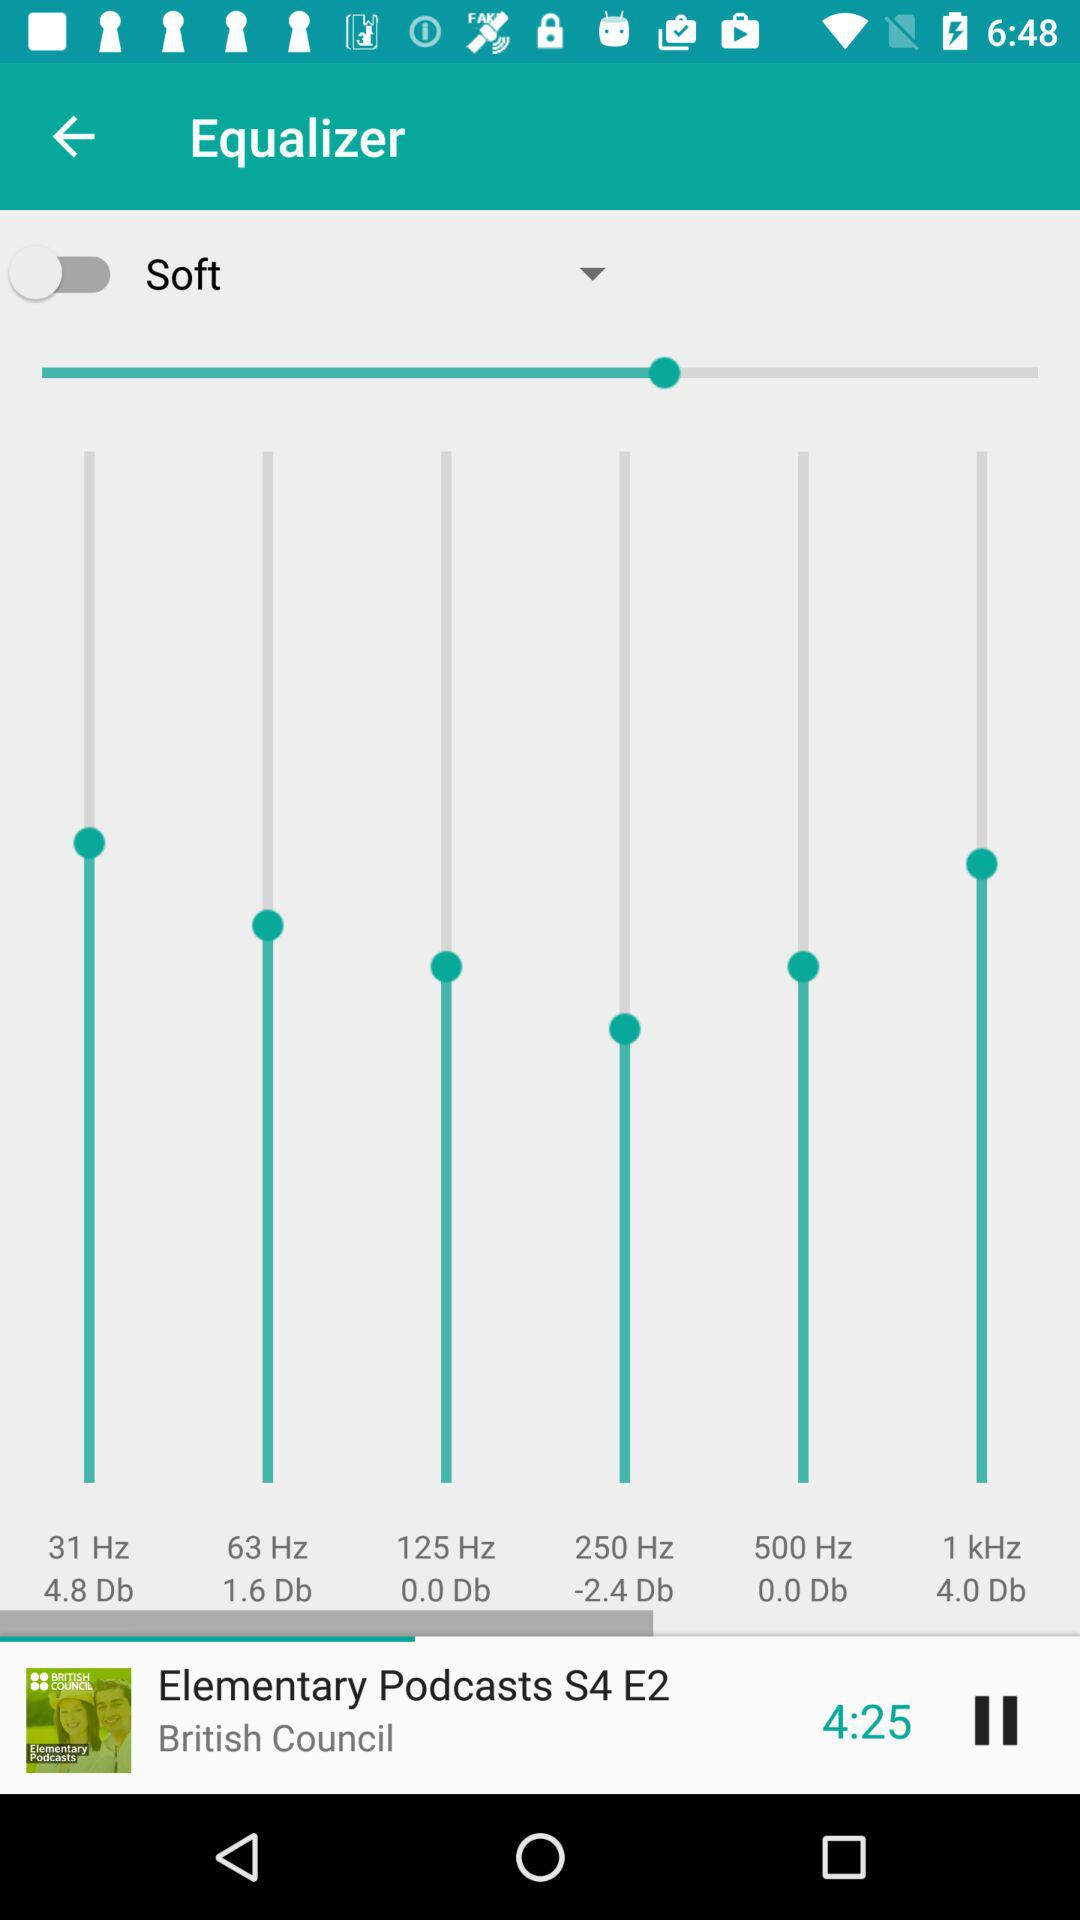What is the name of the series currently playing? The name of the series currently playing is "Elementary Podcasts". 